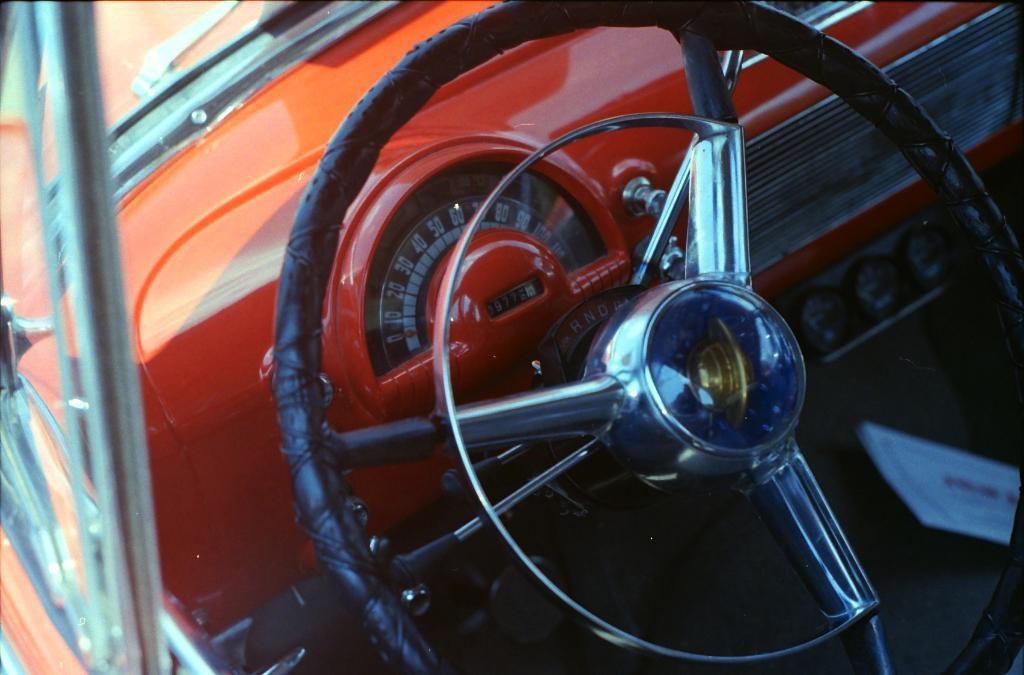Could you give a brief overview of what you see in this image? This is the picture of a vehicle. In this image vehicle is in orange color. There is a steering and there are meters readings. On the left side of the image there is a windshield and there is a window. 